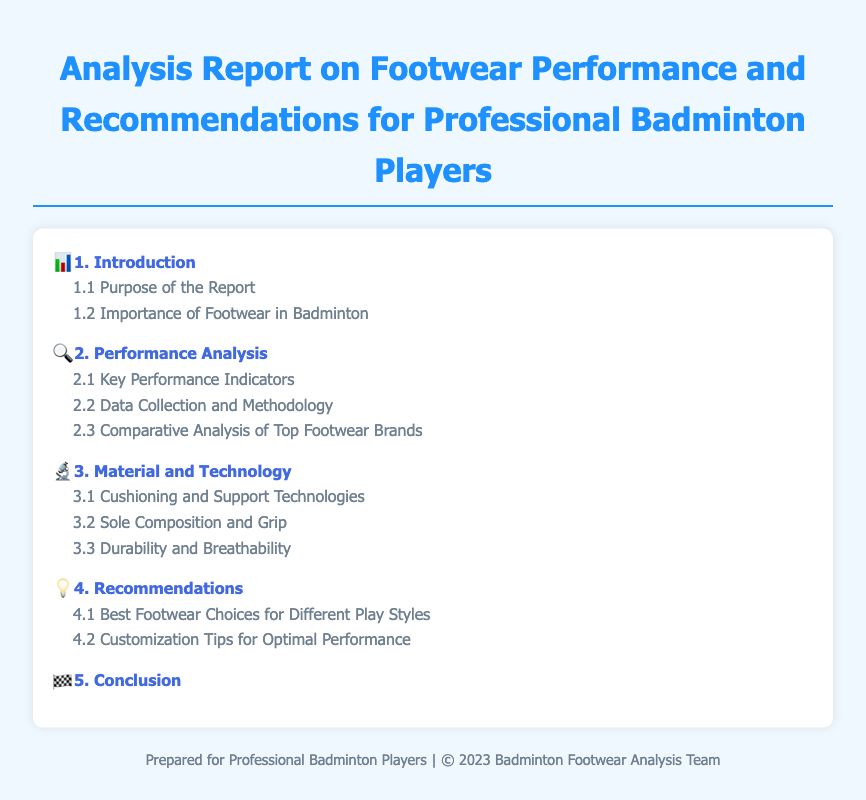What is the title of the report? The title of the report is prominently displayed at the top of the document, which summarizes its content related to footwear performance for badminton players.
Answer: Analysis Report on Footwear Performance and Recommendations for Professional Badminton Players How many sections are in the report? The report is structured into multiple sections, each covering a different aspect of footwear performance and recommendations for badminton players.
Answer: 5 What is the first subsection of Section 2? The first subsection of Section 2 is listed under Performance Analysis, detailing specific metrics used in the evaluation of footwear.
Answer: Key Performance Indicators What type of technology is discussed in Section 3? Section 3 focuses on specific advancements in footwear technology relevant to badminton players, outlining crucial features that enhance performance.
Answer: Cushioning and Support Technologies What recommendations are given for play styles? The report includes tailored footwear suggestions for various playing styles to help players optimize their performance on the court.
Answer: Best Footwear Choices for Different Play Styles What is the purpose of the report? The purpose of the report is specified in the introduction, clarifying its goals and objectives related to footwear performance analysis for badminton players.
Answer: Purpose of the Report What is the focus of subsection 3.2? Subsection 3.2 delves into the characteristics of footwear soles, including materials and their impact on grip, which are vital for badminton performance.
Answer: Sole Composition and Grip 